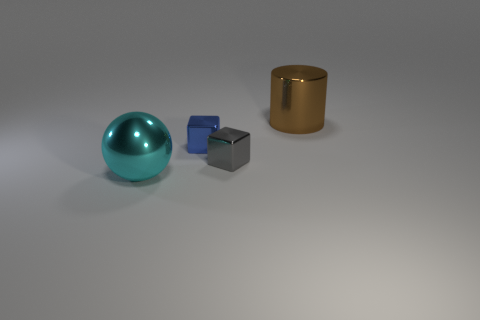There is a big metal thing behind the big cyan sphere; is its shape the same as the small blue object? The big metal object behind the cyan sphere has a cylindrical shape, whereas the small blue object is cube-shaped. Therefore, they have different three-dimensional shapes. The cylindrical object has a circular base and extends vertically, making it distinct from the cube's equal-length sides and angular vertices. 